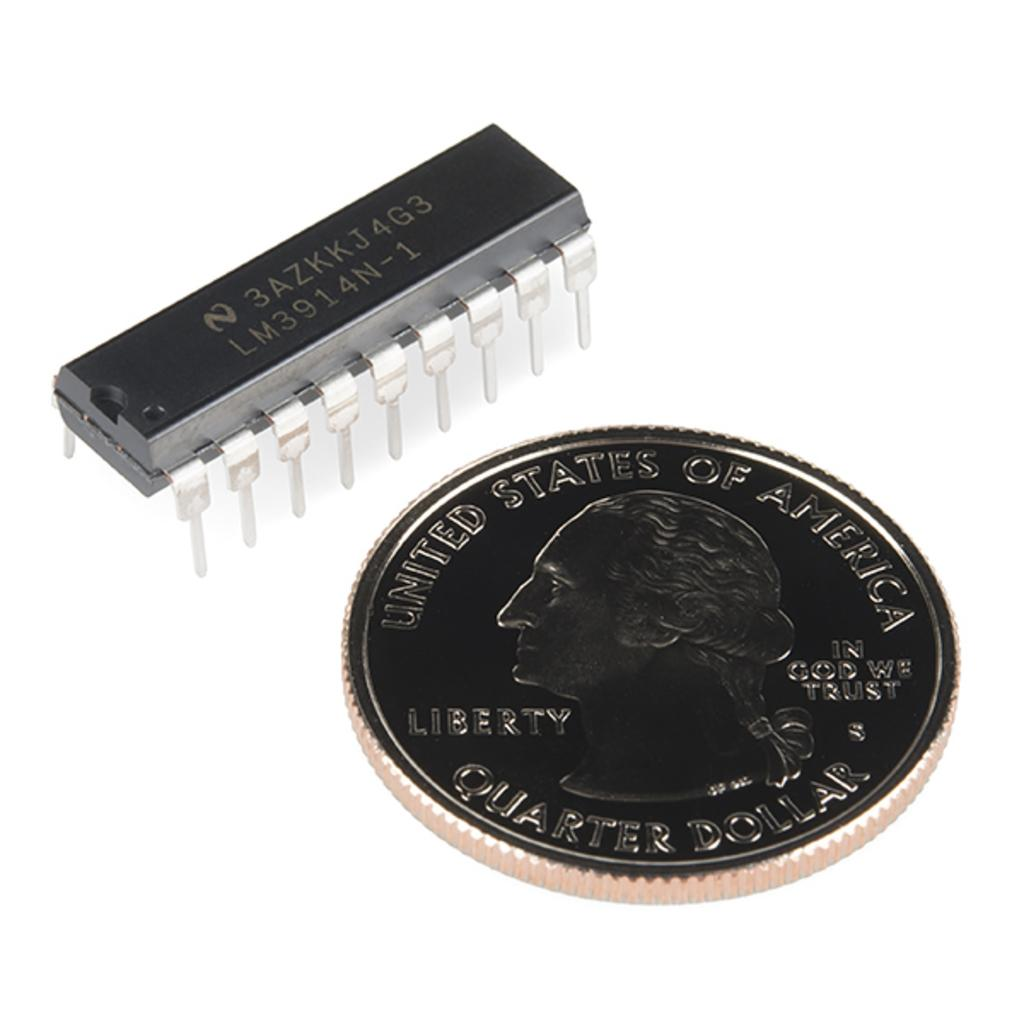<image>
Provide a brief description of the given image. A quarter dollar coin sits next to a computer chip. 